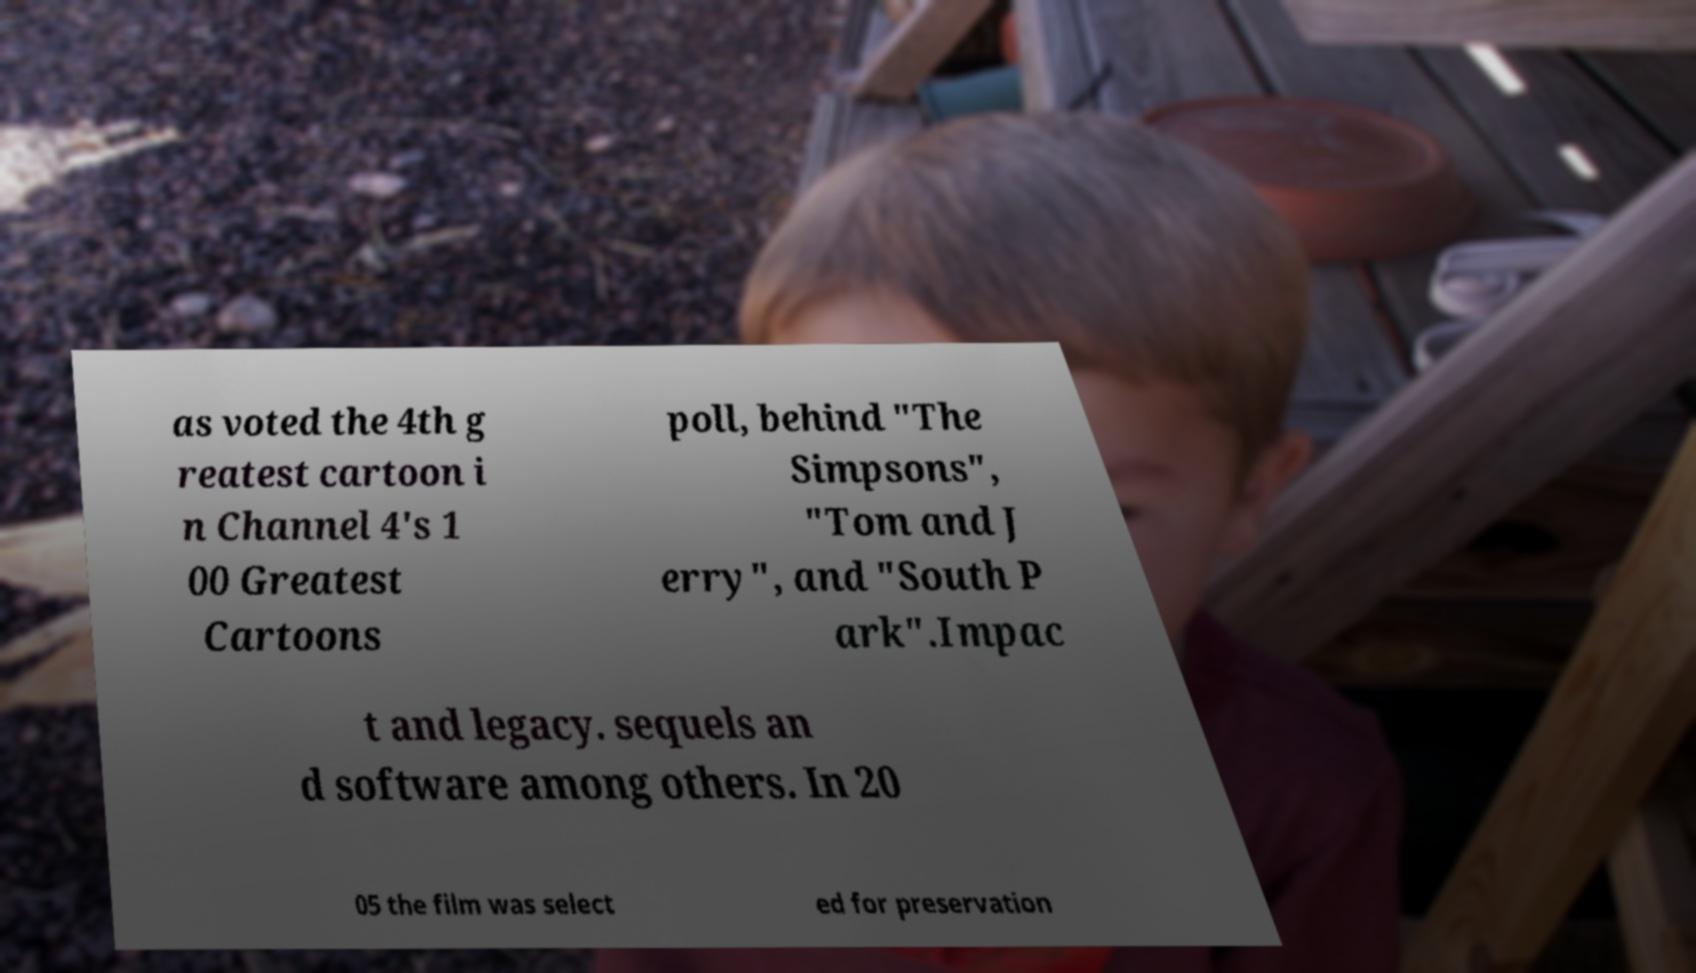Please identify and transcribe the text found in this image. as voted the 4th g reatest cartoon i n Channel 4's 1 00 Greatest Cartoons poll, behind "The Simpsons", "Tom and J erry", and "South P ark".Impac t and legacy. sequels an d software among others. In 20 05 the film was select ed for preservation 